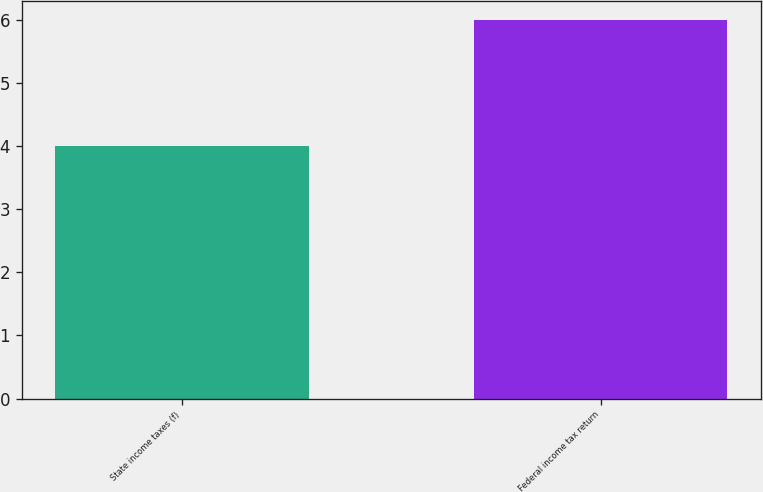<chart> <loc_0><loc_0><loc_500><loc_500><bar_chart><fcel>State income taxes (f)<fcel>Federal income tax return<nl><fcel>4<fcel>6<nl></chart> 